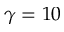Convert formula to latex. <formula><loc_0><loc_0><loc_500><loc_500>\gamma = 1 0</formula> 